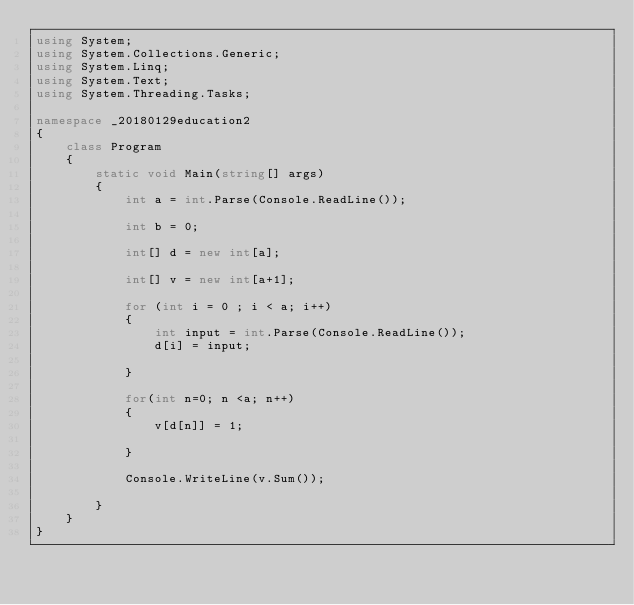Convert code to text. <code><loc_0><loc_0><loc_500><loc_500><_C#_>using System;
using System.Collections.Generic;
using System.Linq;
using System.Text;
using System.Threading.Tasks;

namespace _20180129education2
{
    class Program
    {
        static void Main(string[] args)
        {
            int a = int.Parse(Console.ReadLine());

            int b = 0;

            int[] d = new int[a];

            int[] v = new int[a+1];

            for (int i = 0 ; i < a; i++)
            {
                int input = int.Parse(Console.ReadLine());
                d[i] = input;
             
            }

            for(int n=0; n <a; n++)
            {
                v[d[n]] = 1;
                
            }

            Console.WriteLine(v.Sum());

        }
    }
}</code> 